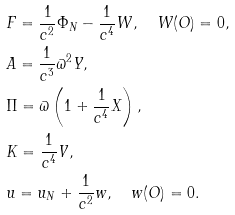Convert formula to latex. <formula><loc_0><loc_0><loc_500><loc_500>& F = \frac { 1 } { c ^ { 2 } } \Phi _ { N } - \frac { 1 } { c ^ { 4 } } W , \quad W ( O ) = 0 , \\ & A = \frac { 1 } { c ^ { 3 } } \varpi ^ { 2 } Y , \\ & \Pi = \varpi \left ( 1 + \frac { 1 } { c ^ { 4 } } X \right ) , \\ & K = \frac { 1 } { c ^ { 4 } } V , \\ & u = u _ { N } + \frac { 1 } { c ^ { 2 } } w , \quad w ( O ) = 0 .</formula> 